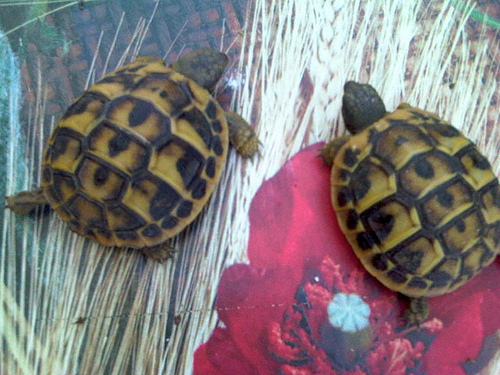<image>
Is there a turtle in front of the turtle? No. The turtle is not in front of the turtle. The spatial positioning shows a different relationship between these objects. 